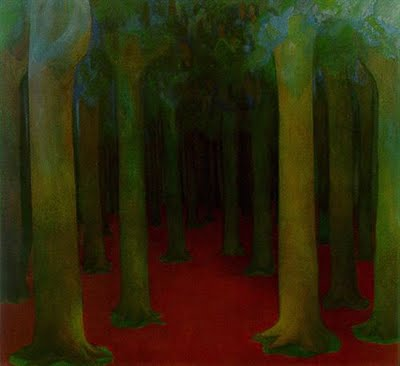What could the striking red color on the forest floor symbolize? The intense red hue covering the forest floor in the painting might symbolize a variety of themes. One interpretation could be that it represents the earth's richness or fertility, emphasizing the life-giving force of nature. Alternatively, it could signify a path or journey, leading the viewer deeper into the emotional or spiritual essence of the forest. The color red also traditionally evokes strong emotions such as passion or vigor, which could be an artistic choice to inject a sense of energy into the otherwise tranquil green of the forest. 